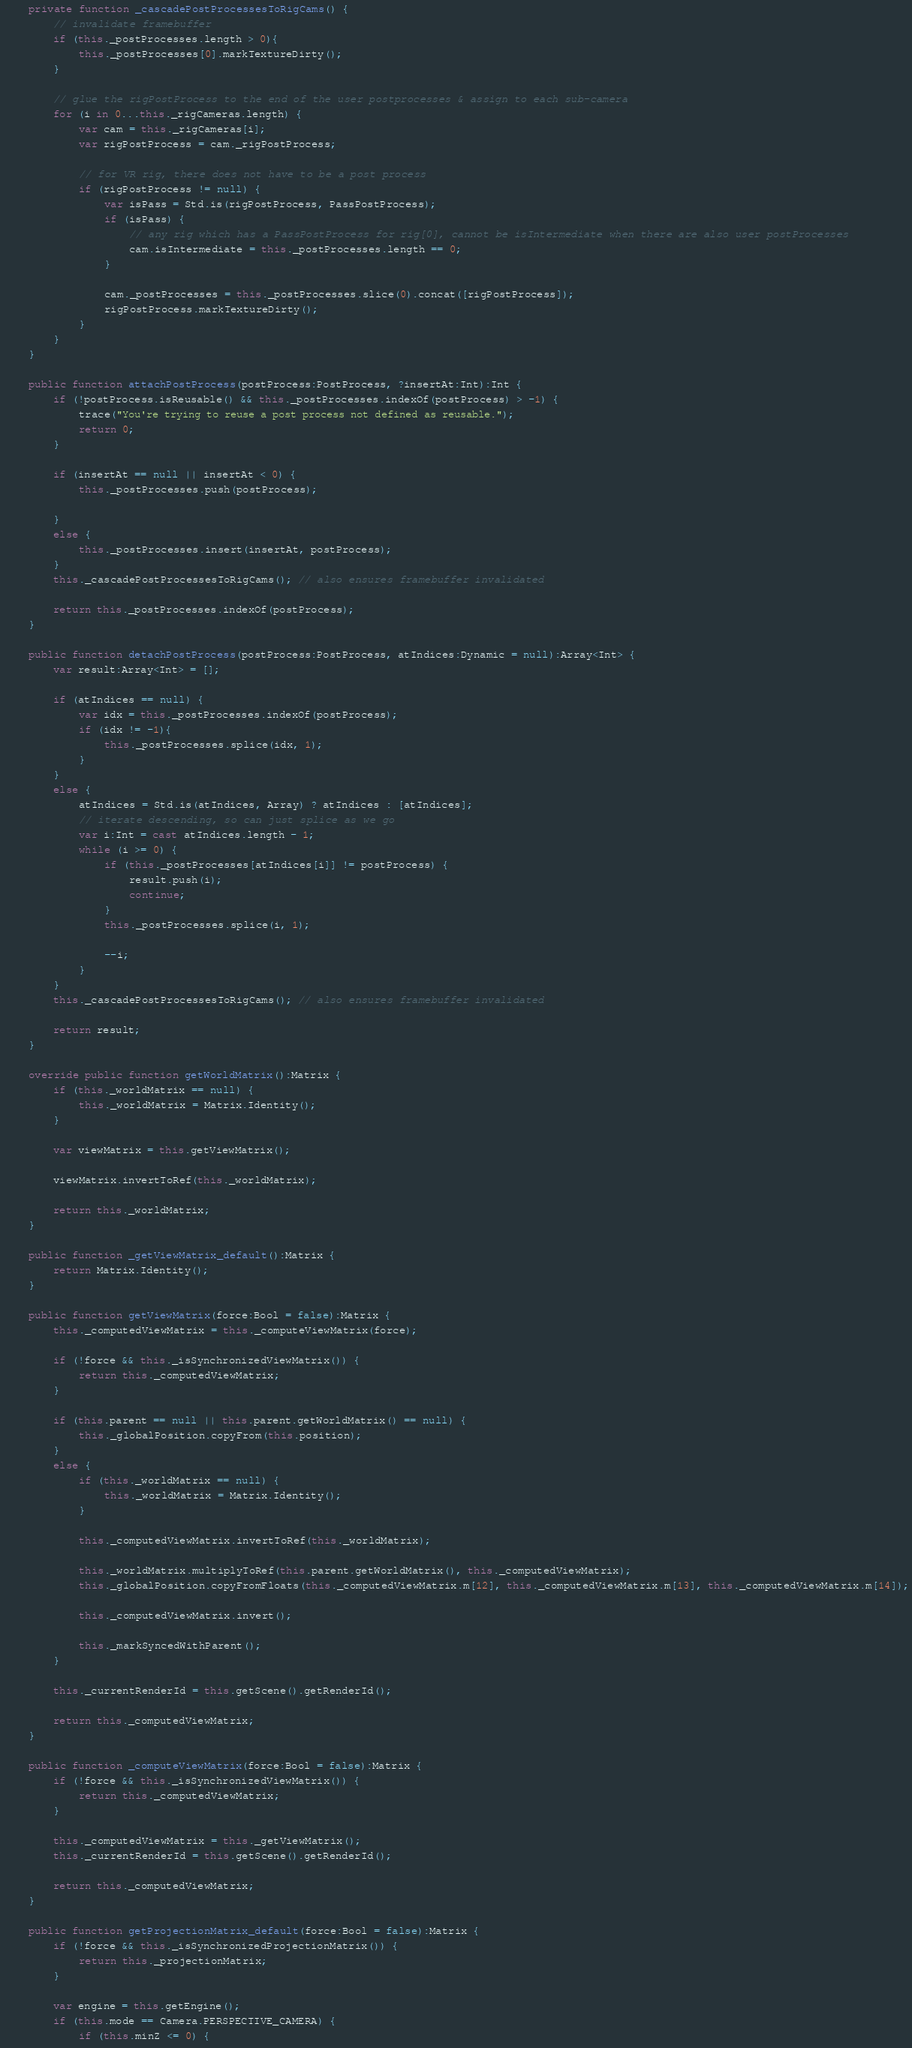<code> <loc_0><loc_0><loc_500><loc_500><_Haxe_>	private function _cascadePostProcessesToRigCams() {
		// invalidate framebuffer
		if (this._postProcesses.length > 0){
			this._postProcesses[0].markTextureDirty();
		}
		
		// glue the rigPostProcess to the end of the user postprocesses & assign to each sub-camera
		for (i in 0...this._rigCameras.length) {
			var cam = this._rigCameras[i];
			var rigPostProcess = cam._rigPostProcess;
			
			// for VR rig, there does not have to be a post process 
			if (rigPostProcess != null) {
				var isPass = Std.is(rigPostProcess, PassPostProcess);
				if (isPass) {
					// any rig which has a PassPostProcess for rig[0], cannot be isIntermediate when there are also user postProcesses
					cam.isIntermediate = this._postProcesses.length == 0;
				}   
				
				cam._postProcesses = this._postProcesses.slice(0).concat([rigPostProcess]);
				rigPostProcess.markTextureDirty();
			}
		}
	}

	public function attachPostProcess(postProcess:PostProcess, ?insertAt:Int):Int {
		if (!postProcess.isReusable() && this._postProcesses.indexOf(postProcess) > -1) {
			trace("You're trying to reuse a post process not defined as reusable.");
			return 0;
		}
		
		if (insertAt == null || insertAt < 0) {
			this._postProcesses.push(postProcess);
			
		}
		else {
			this._postProcesses.insert(insertAt, postProcess);
		}
		this._cascadePostProcessesToRigCams(); // also ensures framebuffer invalidated   
		
		return this._postProcesses.indexOf(postProcess);
	}

	public function detachPostProcess(postProcess:PostProcess, atIndices:Dynamic = null):Array<Int> {
		var result:Array<Int> = [];
		
		if (atIndices == null) {
			var idx = this._postProcesses.indexOf(postProcess);
			if (idx != -1){
				this._postProcesses.splice(idx, 1);
			}
		} 
		else {
			atIndices = Std.is(atIndices, Array) ? atIndices : [atIndices];
			// iterate descending, so can just splice as we go
			var i:Int = cast atIndices.length - 1;
			while (i >= 0) {
				if (this._postProcesses[atIndices[i]] != postProcess) {
					result.push(i);
					continue;
				}
				this._postProcesses.splice(i, 1);
				
				--i;
			}
		}
		this._cascadePostProcessesToRigCams(); // also ensures framebuffer invalidated
		
		return result;
	}

	override public function getWorldMatrix():Matrix {
		if (this._worldMatrix == null) {
			this._worldMatrix = Matrix.Identity();
		}
		
		var viewMatrix = this.getViewMatrix();
		
		viewMatrix.invertToRef(this._worldMatrix);
		
		return this._worldMatrix;
	}

	public function _getViewMatrix_default():Matrix {
		return Matrix.Identity();
	}

	public function getViewMatrix(force:Bool = false):Matrix {
		this._computedViewMatrix = this._computeViewMatrix(force);
		
		if (!force && this._isSynchronizedViewMatrix()) {
			return this._computedViewMatrix;
		}
		
		if (this.parent == null || this.parent.getWorldMatrix() == null) {
			this._globalPosition.copyFrom(this.position);
		} 
		else {
			if (this._worldMatrix == null) {
				this._worldMatrix = Matrix.Identity();
			}
			
			this._computedViewMatrix.invertToRef(this._worldMatrix);
			
			this._worldMatrix.multiplyToRef(this.parent.getWorldMatrix(), this._computedViewMatrix);
			this._globalPosition.copyFromFloats(this._computedViewMatrix.m[12], this._computedViewMatrix.m[13], this._computedViewMatrix.m[14]);
			
			this._computedViewMatrix.invert();
			
			this._markSyncedWithParent();
		}
		
		this._currentRenderId = this.getScene().getRenderId();
		
		return this._computedViewMatrix;
	}

	public function _computeViewMatrix(force:Bool = false):Matrix {
		if (!force && this._isSynchronizedViewMatrix()) {
			return this._computedViewMatrix;
		}
		
		this._computedViewMatrix = this._getViewMatrix();		
		this._currentRenderId = this.getScene().getRenderId();
		
		return this._computedViewMatrix;
	}

	public function getProjectionMatrix_default(force:Bool = false):Matrix {
		if (!force && this._isSynchronizedProjectionMatrix()) {
			return this._projectionMatrix;
		}
		
		var engine = this.getEngine();
		if (this.mode == Camera.PERSPECTIVE_CAMERA) {
			if (this.minZ <= 0) {</code> 